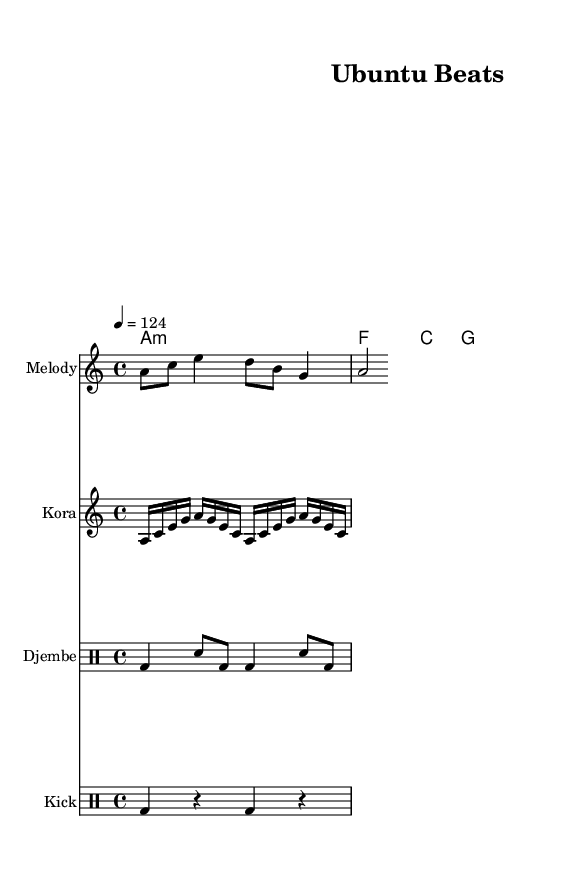What is the key signature of this music? The key signature is A minor, which includes no sharps or flats, indicated by the absence of any key signature symbols before the staff.
Answer: A minor What is the time signature of this music? The time signature is 4/4, as noted at the beginning of the staff with two numbers, where the upper number indicates four beats in a measure and the lower number indicates a quarter note gets one beat.
Answer: 4/4 What is the tempo marking of this piece? The tempo marking is 124 beats per minute, indicated by the text "4 = 124" at the beginning, which specifies how fast the piece should be played.
Answer: 124 What instruments are included in this score? The score includes Melody, Kora, Djembe, and Kick, as noted by their respective instrument names above each staff in the score layout.
Answer: Melody, Kora, Djembe, Kick How many measures are present in the Melody section? The Melody section has four measures, as counted in the first staff which shows the grouping of notes within the beams and bar lines.
Answer: 4 What is the rhythmic pattern of the Djembe part? The rhythmic pattern consists of a bass drum followed by snare and repeats the sequence of bass and snare, which can be analyzed by looking closely at the drummode notation indicated in the Djembe staff.
Answer: bass-snare-bass-bass-snare-bass What type of chords are used in the harmony section? The harmony section includes a combination of A minor, F major, C major, and G major chords, outlined in the chordmode section and represented visually by the stacked notes.
Answer: A minor, F, C, G 